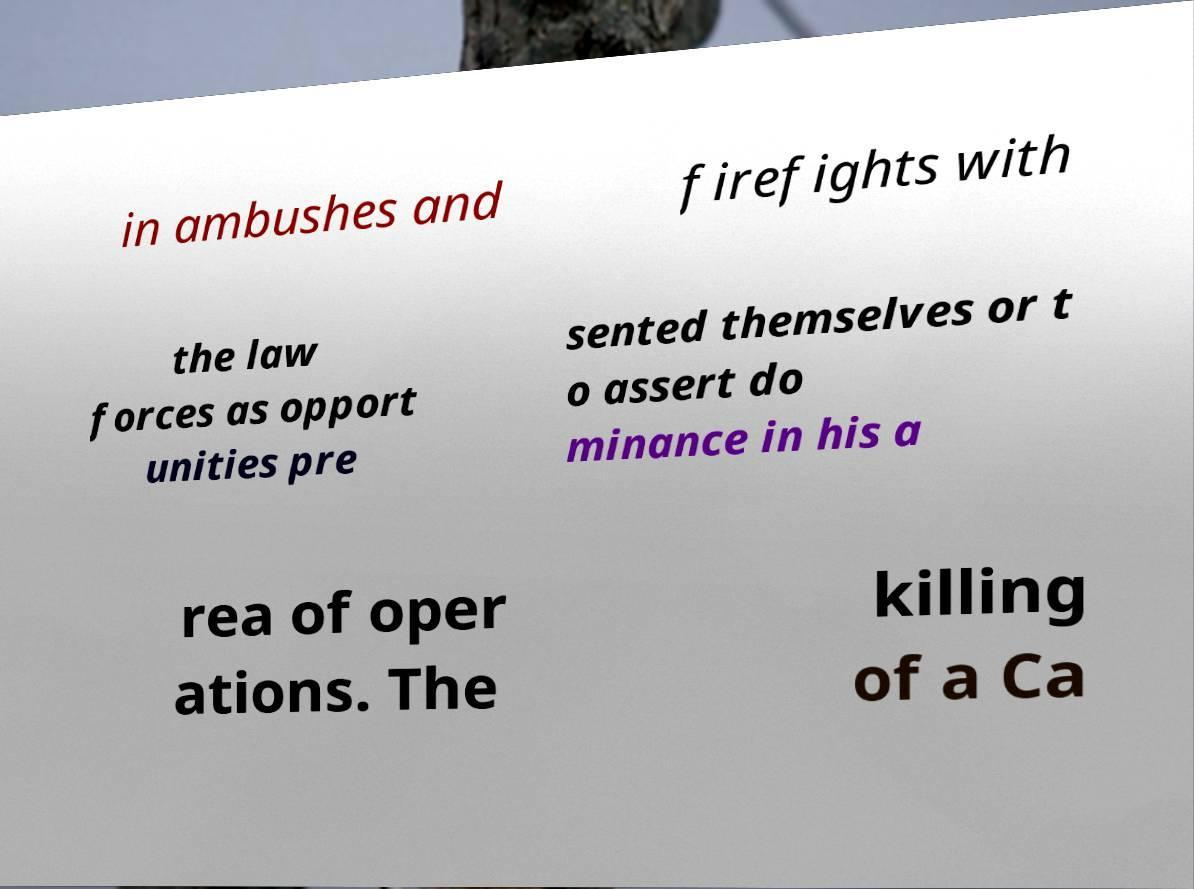Could you assist in decoding the text presented in this image and type it out clearly? in ambushes and firefights with the law forces as opport unities pre sented themselves or t o assert do minance in his a rea of oper ations. The killing of a Ca 